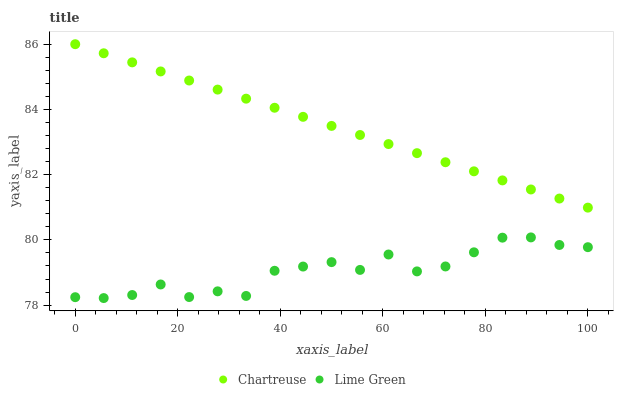Does Lime Green have the minimum area under the curve?
Answer yes or no. Yes. Does Chartreuse have the maximum area under the curve?
Answer yes or no. Yes. Does Lime Green have the maximum area under the curve?
Answer yes or no. No. Is Chartreuse the smoothest?
Answer yes or no. Yes. Is Lime Green the roughest?
Answer yes or no. Yes. Is Lime Green the smoothest?
Answer yes or no. No. Does Lime Green have the lowest value?
Answer yes or no. Yes. Does Chartreuse have the highest value?
Answer yes or no. Yes. Does Lime Green have the highest value?
Answer yes or no. No. Is Lime Green less than Chartreuse?
Answer yes or no. Yes. Is Chartreuse greater than Lime Green?
Answer yes or no. Yes. Does Lime Green intersect Chartreuse?
Answer yes or no. No. 